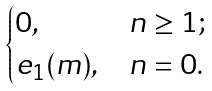Convert formula to latex. <formula><loc_0><loc_0><loc_500><loc_500>\begin{cases} 0 , & n \geq 1 ; \\ e _ { 1 } ( m ) , & n = 0 . \end{cases}</formula> 